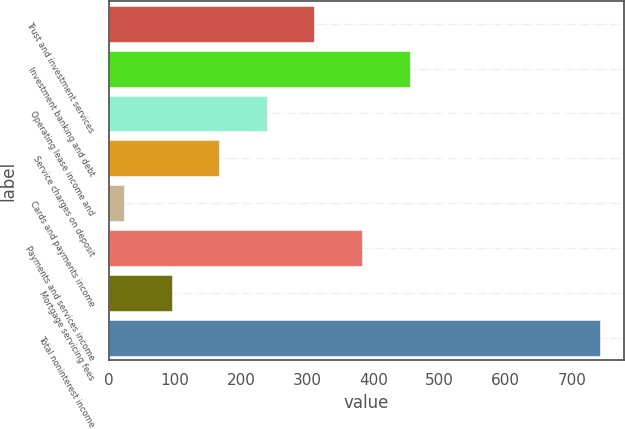<chart> <loc_0><loc_0><loc_500><loc_500><bar_chart><fcel>Trust and investment services<fcel>Investment banking and debt<fcel>Operating lease income and<fcel>Service charges on deposit<fcel>Cards and payments income<fcel>Payments and services income<fcel>Mortgage servicing fees<fcel>Total noninterest income<nl><fcel>310.6<fcel>454.4<fcel>238.7<fcel>166.8<fcel>23<fcel>382.5<fcel>94.9<fcel>742<nl></chart> 